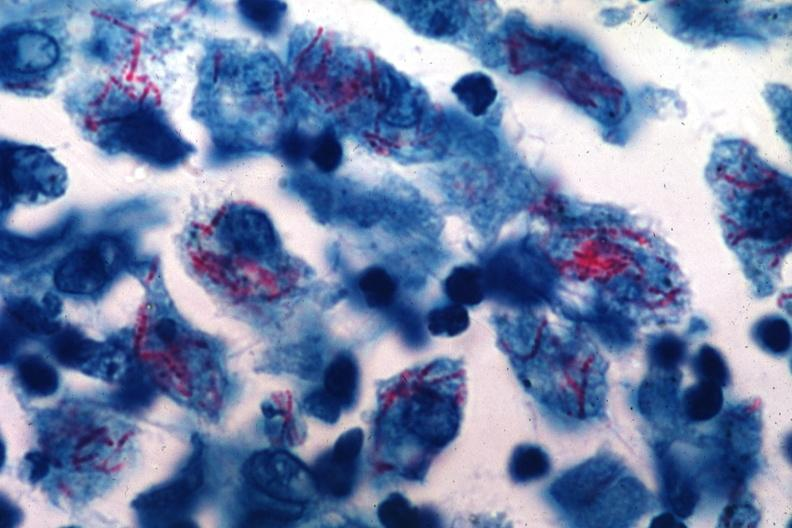what is present?
Answer the question using a single word or phrase. Tuberculosis 